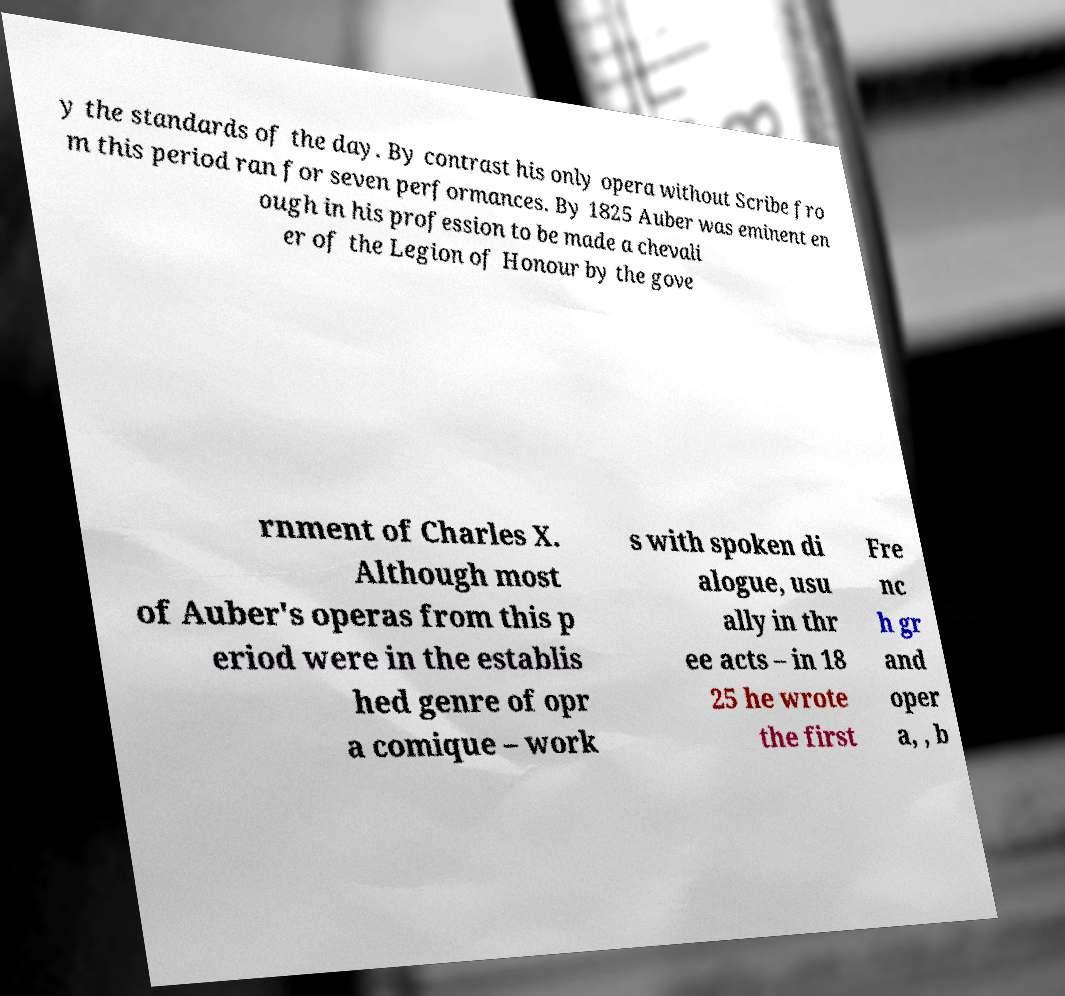What messages or text are displayed in this image? I need them in a readable, typed format. y the standards of the day. By contrast his only opera without Scribe fro m this period ran for seven performances. By 1825 Auber was eminent en ough in his profession to be made a chevali er of the Legion of Honour by the gove rnment of Charles X. Although most of Auber's operas from this p eriod were in the establis hed genre of opr a comique – work s with spoken di alogue, usu ally in thr ee acts – in 18 25 he wrote the first Fre nc h gr and oper a, , b 